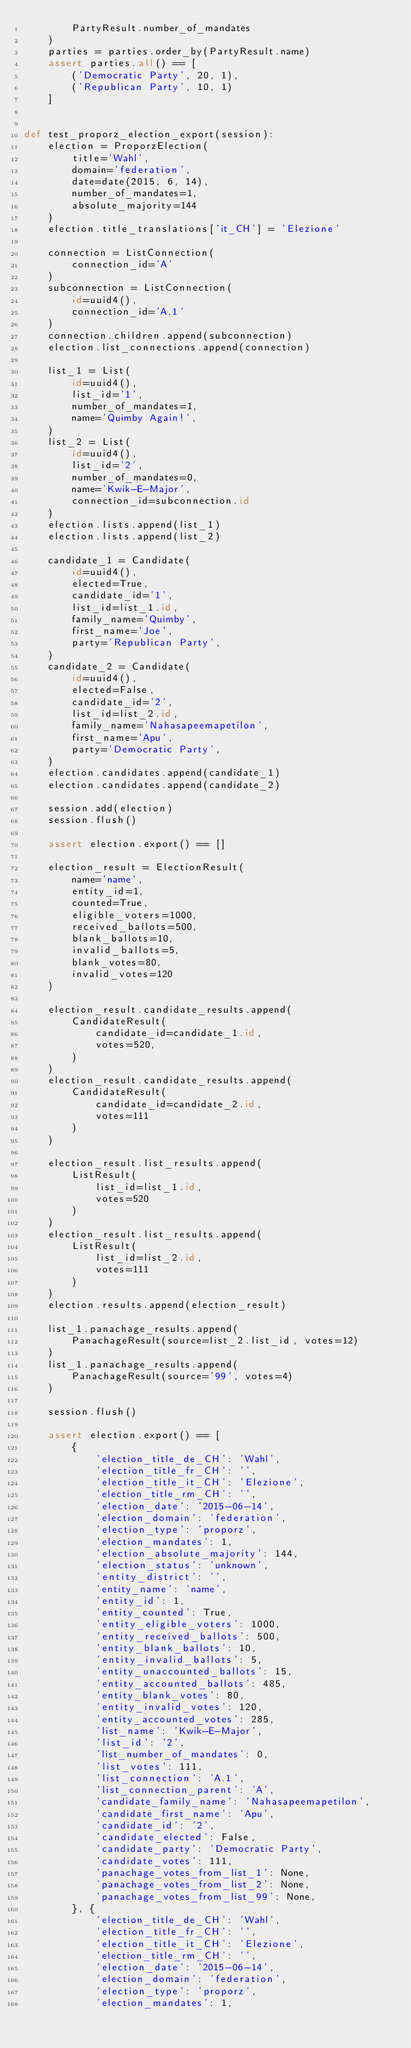Convert code to text. <code><loc_0><loc_0><loc_500><loc_500><_Python_>        PartyResult.number_of_mandates
    )
    parties = parties.order_by(PartyResult.name)
    assert parties.all() == [
        ('Democratic Party', 20, 1),
        ('Republican Party', 10, 1)
    ]


def test_proporz_election_export(session):
    election = ProporzElection(
        title='Wahl',
        domain='federation',
        date=date(2015, 6, 14),
        number_of_mandates=1,
        absolute_majority=144
    )
    election.title_translations['it_CH'] = 'Elezione'

    connection = ListConnection(
        connection_id='A'
    )
    subconnection = ListConnection(
        id=uuid4(),
        connection_id='A.1'
    )
    connection.children.append(subconnection)
    election.list_connections.append(connection)

    list_1 = List(
        id=uuid4(),
        list_id='1',
        number_of_mandates=1,
        name='Quimby Again!',
    )
    list_2 = List(
        id=uuid4(),
        list_id='2',
        number_of_mandates=0,
        name='Kwik-E-Major',
        connection_id=subconnection.id
    )
    election.lists.append(list_1)
    election.lists.append(list_2)

    candidate_1 = Candidate(
        id=uuid4(),
        elected=True,
        candidate_id='1',
        list_id=list_1.id,
        family_name='Quimby',
        first_name='Joe',
        party='Republican Party',
    )
    candidate_2 = Candidate(
        id=uuid4(),
        elected=False,
        candidate_id='2',
        list_id=list_2.id,
        family_name='Nahasapeemapetilon',
        first_name='Apu',
        party='Democratic Party',
    )
    election.candidates.append(candidate_1)
    election.candidates.append(candidate_2)

    session.add(election)
    session.flush()

    assert election.export() == []

    election_result = ElectionResult(
        name='name',
        entity_id=1,
        counted=True,
        eligible_voters=1000,
        received_ballots=500,
        blank_ballots=10,
        invalid_ballots=5,
        blank_votes=80,
        invalid_votes=120
    )

    election_result.candidate_results.append(
        CandidateResult(
            candidate_id=candidate_1.id,
            votes=520,
        )
    )
    election_result.candidate_results.append(
        CandidateResult(
            candidate_id=candidate_2.id,
            votes=111
        )
    )

    election_result.list_results.append(
        ListResult(
            list_id=list_1.id,
            votes=520
        )
    )
    election_result.list_results.append(
        ListResult(
            list_id=list_2.id,
            votes=111
        )
    )
    election.results.append(election_result)

    list_1.panachage_results.append(
        PanachageResult(source=list_2.list_id, votes=12)
    )
    list_1.panachage_results.append(
        PanachageResult(source='99', votes=4)
    )

    session.flush()

    assert election.export() == [
        {
            'election_title_de_CH': 'Wahl',
            'election_title_fr_CH': '',
            'election_title_it_CH': 'Elezione',
            'election_title_rm_CH': '',
            'election_date': '2015-06-14',
            'election_domain': 'federation',
            'election_type': 'proporz',
            'election_mandates': 1,
            'election_absolute_majority': 144,
            'election_status': 'unknown',
            'entity_district': '',
            'entity_name': 'name',
            'entity_id': 1,
            'entity_counted': True,
            'entity_eligible_voters': 1000,
            'entity_received_ballots': 500,
            'entity_blank_ballots': 10,
            'entity_invalid_ballots': 5,
            'entity_unaccounted_ballots': 15,
            'entity_accounted_ballots': 485,
            'entity_blank_votes': 80,
            'entity_invalid_votes': 120,
            'entity_accounted_votes': 285,
            'list_name': 'Kwik-E-Major',
            'list_id': '2',
            'list_number_of_mandates': 0,
            'list_votes': 111,
            'list_connection': 'A.1',
            'list_connection_parent': 'A',
            'candidate_family_name': 'Nahasapeemapetilon',
            'candidate_first_name': 'Apu',
            'candidate_id': '2',
            'candidate_elected': False,
            'candidate_party': 'Democratic Party',
            'candidate_votes': 111,
            'panachage_votes_from_list_1': None,
            'panachage_votes_from_list_2': None,
            'panachage_votes_from_list_99': None,
        }, {
            'election_title_de_CH': 'Wahl',
            'election_title_fr_CH': '',
            'election_title_it_CH': 'Elezione',
            'election_title_rm_CH': '',
            'election_date': '2015-06-14',
            'election_domain': 'federation',
            'election_type': 'proporz',
            'election_mandates': 1,</code> 